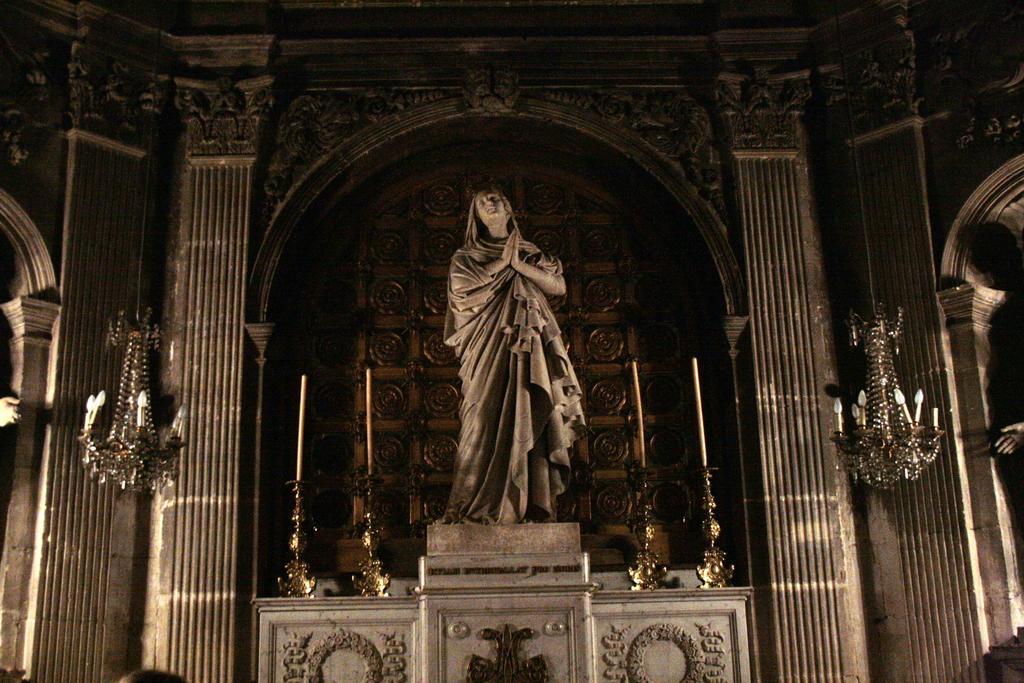In one or two sentences, can you explain what this image depicts? This is an inside picture of the church, we can see sculpture, pillars, lights and some other objects. 